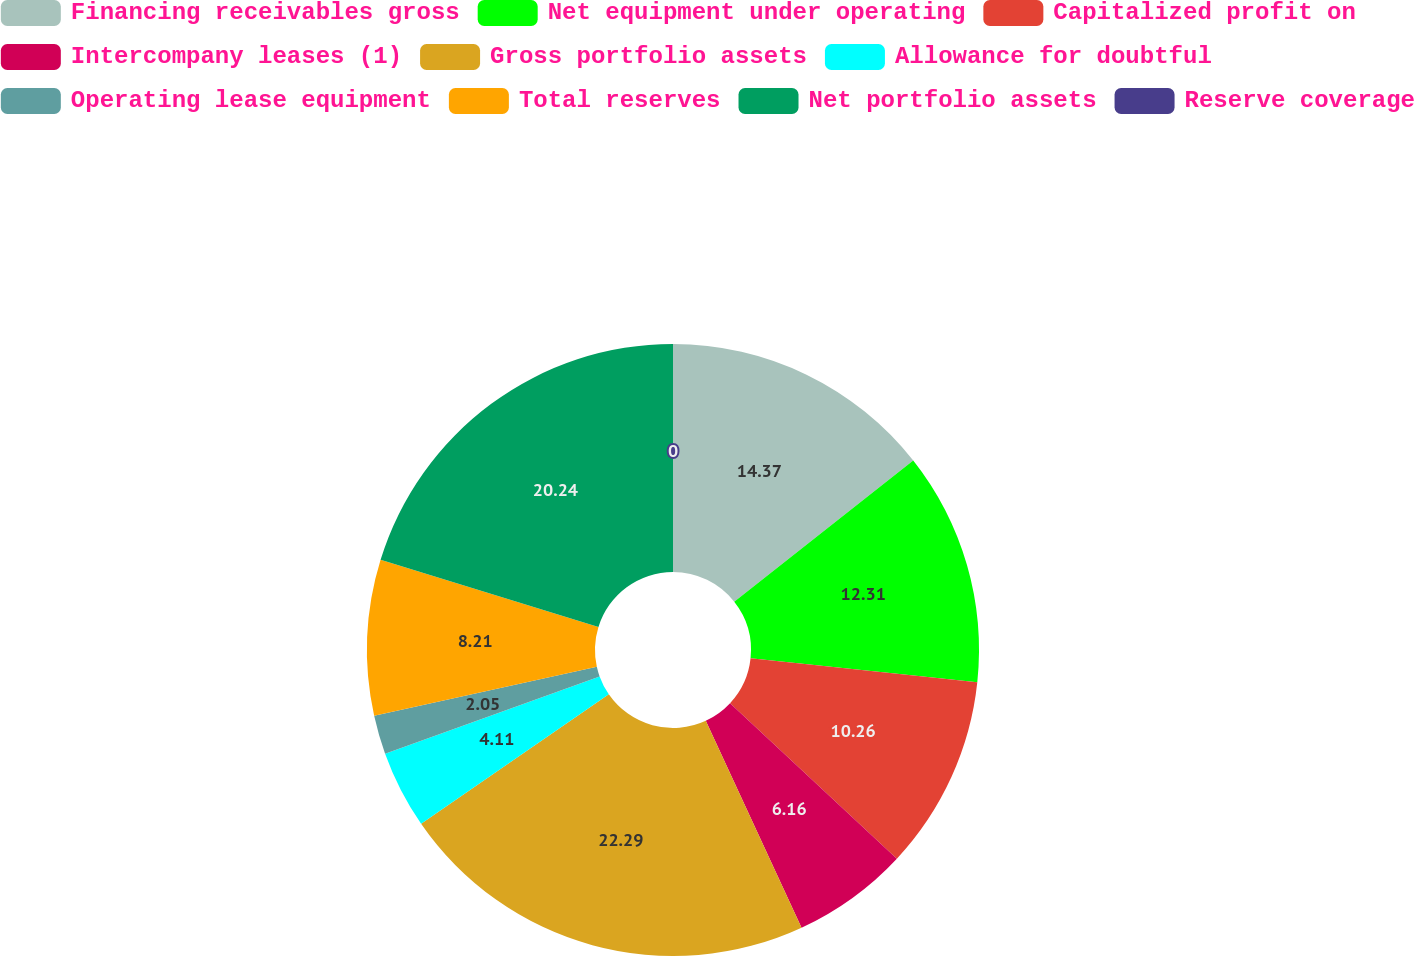<chart> <loc_0><loc_0><loc_500><loc_500><pie_chart><fcel>Financing receivables gross<fcel>Net equipment under operating<fcel>Capitalized profit on<fcel>Intercompany leases (1)<fcel>Gross portfolio assets<fcel>Allowance for doubtful<fcel>Operating lease equipment<fcel>Total reserves<fcel>Net portfolio assets<fcel>Reserve coverage<nl><fcel>14.37%<fcel>12.31%<fcel>10.26%<fcel>6.16%<fcel>22.29%<fcel>4.11%<fcel>2.05%<fcel>8.21%<fcel>20.24%<fcel>0.0%<nl></chart> 